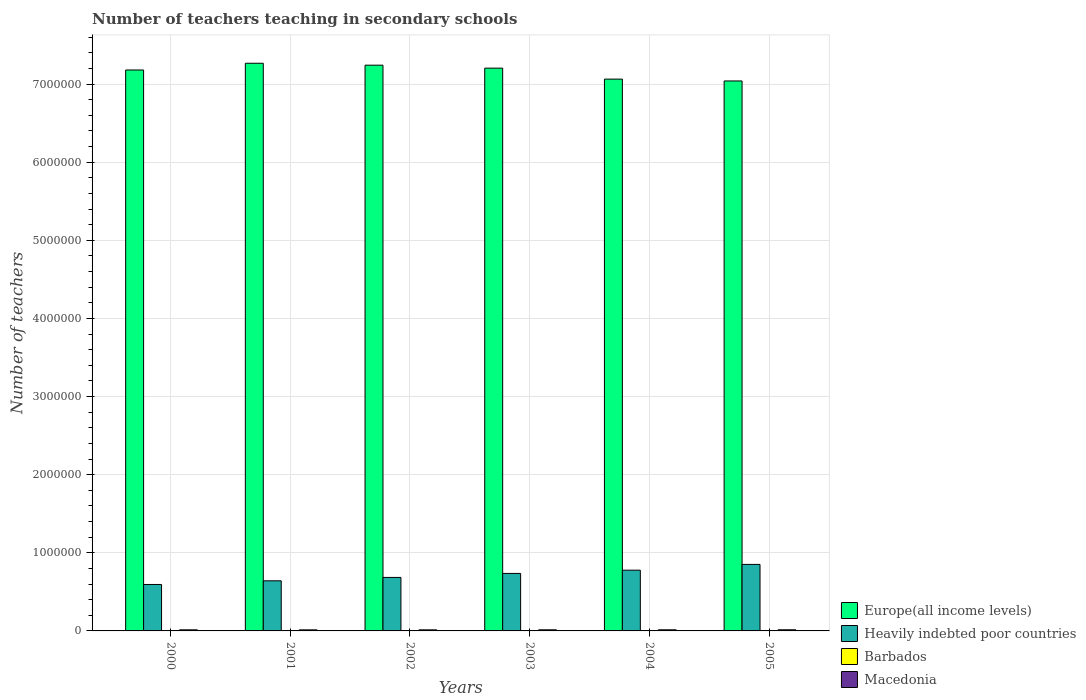Are the number of bars per tick equal to the number of legend labels?
Give a very brief answer. Yes. Are the number of bars on each tick of the X-axis equal?
Make the answer very short. Yes. How many bars are there on the 2nd tick from the left?
Give a very brief answer. 4. How many bars are there on the 5th tick from the right?
Offer a terse response. 4. What is the label of the 4th group of bars from the left?
Keep it short and to the point. 2003. What is the number of teachers teaching in secondary schools in Barbados in 2000?
Ensure brevity in your answer.  1215. Across all years, what is the maximum number of teachers teaching in secondary schools in Macedonia?
Provide a short and direct response. 1.46e+04. Across all years, what is the minimum number of teachers teaching in secondary schools in Heavily indebted poor countries?
Make the answer very short. 5.95e+05. In which year was the number of teachers teaching in secondary schools in Barbados minimum?
Your answer should be compact. 2001. What is the total number of teachers teaching in secondary schools in Heavily indebted poor countries in the graph?
Your answer should be very brief. 4.29e+06. What is the difference between the number of teachers teaching in secondary schools in Europe(all income levels) in 2002 and that in 2005?
Make the answer very short. 2.02e+05. What is the difference between the number of teachers teaching in secondary schools in Macedonia in 2000 and the number of teachers teaching in secondary schools in Barbados in 2003?
Provide a short and direct response. 1.25e+04. What is the average number of teachers teaching in secondary schools in Europe(all income levels) per year?
Provide a succinct answer. 7.17e+06. In the year 2004, what is the difference between the number of teachers teaching in secondary schools in Heavily indebted poor countries and number of teachers teaching in secondary schools in Macedonia?
Keep it short and to the point. 7.63e+05. In how many years, is the number of teachers teaching in secondary schools in Macedonia greater than 5200000?
Your answer should be compact. 0. What is the ratio of the number of teachers teaching in secondary schools in Europe(all income levels) in 2003 to that in 2005?
Offer a very short reply. 1.02. Is the difference between the number of teachers teaching in secondary schools in Heavily indebted poor countries in 2001 and 2005 greater than the difference between the number of teachers teaching in secondary schools in Macedonia in 2001 and 2005?
Give a very brief answer. No. What is the difference between the highest and the second highest number of teachers teaching in secondary schools in Europe(all income levels)?
Give a very brief answer. 2.47e+04. What is the difference between the highest and the lowest number of teachers teaching in secondary schools in Macedonia?
Ensure brevity in your answer.  979. What does the 2nd bar from the left in 2004 represents?
Give a very brief answer. Heavily indebted poor countries. What does the 3rd bar from the right in 2001 represents?
Give a very brief answer. Heavily indebted poor countries. Is it the case that in every year, the sum of the number of teachers teaching in secondary schools in Barbados and number of teachers teaching in secondary schools in Macedonia is greater than the number of teachers teaching in secondary schools in Heavily indebted poor countries?
Keep it short and to the point. No. How many bars are there?
Provide a short and direct response. 24. Are all the bars in the graph horizontal?
Keep it short and to the point. No. How many years are there in the graph?
Provide a short and direct response. 6. What is the difference between two consecutive major ticks on the Y-axis?
Your response must be concise. 1.00e+06. Does the graph contain any zero values?
Provide a succinct answer. No. How many legend labels are there?
Offer a very short reply. 4. How are the legend labels stacked?
Ensure brevity in your answer.  Vertical. What is the title of the graph?
Offer a very short reply. Number of teachers teaching in secondary schools. Does "Somalia" appear as one of the legend labels in the graph?
Your answer should be very brief. No. What is the label or title of the Y-axis?
Provide a short and direct response. Number of teachers. What is the Number of teachers of Europe(all income levels) in 2000?
Your answer should be very brief. 7.18e+06. What is the Number of teachers in Heavily indebted poor countries in 2000?
Provide a short and direct response. 5.95e+05. What is the Number of teachers in Barbados in 2000?
Keep it short and to the point. 1215. What is the Number of teachers of Macedonia in 2000?
Provide a succinct answer. 1.38e+04. What is the Number of teachers of Europe(all income levels) in 2001?
Offer a terse response. 7.27e+06. What is the Number of teachers of Heavily indebted poor countries in 2001?
Your response must be concise. 6.42e+05. What is the Number of teachers of Barbados in 2001?
Provide a short and direct response. 1210. What is the Number of teachers of Macedonia in 2001?
Offer a very short reply. 1.36e+04. What is the Number of teachers in Europe(all income levels) in 2002?
Offer a terse response. 7.24e+06. What is the Number of teachers of Heavily indebted poor countries in 2002?
Ensure brevity in your answer.  6.85e+05. What is the Number of teachers of Barbados in 2002?
Offer a terse response. 1326. What is the Number of teachers of Macedonia in 2002?
Provide a short and direct response. 1.36e+04. What is the Number of teachers in Europe(all income levels) in 2003?
Your answer should be compact. 7.20e+06. What is the Number of teachers of Heavily indebted poor countries in 2003?
Your answer should be compact. 7.36e+05. What is the Number of teachers in Barbados in 2003?
Keep it short and to the point. 1381. What is the Number of teachers of Macedonia in 2003?
Make the answer very short. 1.40e+04. What is the Number of teachers in Europe(all income levels) in 2004?
Your answer should be very brief. 7.06e+06. What is the Number of teachers in Heavily indebted poor countries in 2004?
Provide a succinct answer. 7.78e+05. What is the Number of teachers of Barbados in 2004?
Make the answer very short. 1264. What is the Number of teachers of Macedonia in 2004?
Offer a terse response. 1.43e+04. What is the Number of teachers in Europe(all income levels) in 2005?
Ensure brevity in your answer.  7.04e+06. What is the Number of teachers in Heavily indebted poor countries in 2005?
Keep it short and to the point. 8.52e+05. What is the Number of teachers in Barbados in 2005?
Offer a terse response. 1348. What is the Number of teachers of Macedonia in 2005?
Your response must be concise. 1.46e+04. Across all years, what is the maximum Number of teachers in Europe(all income levels)?
Offer a very short reply. 7.27e+06. Across all years, what is the maximum Number of teachers in Heavily indebted poor countries?
Make the answer very short. 8.52e+05. Across all years, what is the maximum Number of teachers of Barbados?
Make the answer very short. 1381. Across all years, what is the maximum Number of teachers of Macedonia?
Keep it short and to the point. 1.46e+04. Across all years, what is the minimum Number of teachers in Europe(all income levels)?
Your answer should be compact. 7.04e+06. Across all years, what is the minimum Number of teachers of Heavily indebted poor countries?
Your response must be concise. 5.95e+05. Across all years, what is the minimum Number of teachers in Barbados?
Your response must be concise. 1210. Across all years, what is the minimum Number of teachers of Macedonia?
Offer a terse response. 1.36e+04. What is the total Number of teachers in Europe(all income levels) in the graph?
Keep it short and to the point. 4.30e+07. What is the total Number of teachers in Heavily indebted poor countries in the graph?
Offer a very short reply. 4.29e+06. What is the total Number of teachers in Barbados in the graph?
Ensure brevity in your answer.  7744. What is the total Number of teachers in Macedonia in the graph?
Ensure brevity in your answer.  8.38e+04. What is the difference between the Number of teachers of Europe(all income levels) in 2000 and that in 2001?
Ensure brevity in your answer.  -8.63e+04. What is the difference between the Number of teachers in Heavily indebted poor countries in 2000 and that in 2001?
Give a very brief answer. -4.70e+04. What is the difference between the Number of teachers of Barbados in 2000 and that in 2001?
Keep it short and to the point. 5. What is the difference between the Number of teachers of Macedonia in 2000 and that in 2001?
Keep it short and to the point. 262. What is the difference between the Number of teachers of Europe(all income levels) in 2000 and that in 2002?
Your answer should be compact. -6.16e+04. What is the difference between the Number of teachers in Heavily indebted poor countries in 2000 and that in 2002?
Provide a succinct answer. -9.01e+04. What is the difference between the Number of teachers of Barbados in 2000 and that in 2002?
Provide a succinct answer. -111. What is the difference between the Number of teachers of Macedonia in 2000 and that in 2002?
Give a very brief answer. 203. What is the difference between the Number of teachers in Europe(all income levels) in 2000 and that in 2003?
Keep it short and to the point. -2.36e+04. What is the difference between the Number of teachers in Heavily indebted poor countries in 2000 and that in 2003?
Your answer should be very brief. -1.41e+05. What is the difference between the Number of teachers of Barbados in 2000 and that in 2003?
Offer a very short reply. -166. What is the difference between the Number of teachers of Macedonia in 2000 and that in 2003?
Your answer should be very brief. -172. What is the difference between the Number of teachers of Europe(all income levels) in 2000 and that in 2004?
Your answer should be very brief. 1.17e+05. What is the difference between the Number of teachers in Heavily indebted poor countries in 2000 and that in 2004?
Your answer should be compact. -1.83e+05. What is the difference between the Number of teachers in Barbados in 2000 and that in 2004?
Your answer should be compact. -49. What is the difference between the Number of teachers in Macedonia in 2000 and that in 2004?
Offer a very short reply. -427. What is the difference between the Number of teachers in Europe(all income levels) in 2000 and that in 2005?
Provide a succinct answer. 1.40e+05. What is the difference between the Number of teachers of Heavily indebted poor countries in 2000 and that in 2005?
Give a very brief answer. -2.57e+05. What is the difference between the Number of teachers in Barbados in 2000 and that in 2005?
Offer a terse response. -133. What is the difference between the Number of teachers in Macedonia in 2000 and that in 2005?
Your answer should be very brief. -717. What is the difference between the Number of teachers in Europe(all income levels) in 2001 and that in 2002?
Offer a terse response. 2.47e+04. What is the difference between the Number of teachers of Heavily indebted poor countries in 2001 and that in 2002?
Your answer should be very brief. -4.31e+04. What is the difference between the Number of teachers in Barbados in 2001 and that in 2002?
Your answer should be very brief. -116. What is the difference between the Number of teachers of Macedonia in 2001 and that in 2002?
Ensure brevity in your answer.  -59. What is the difference between the Number of teachers of Europe(all income levels) in 2001 and that in 2003?
Your answer should be very brief. 6.26e+04. What is the difference between the Number of teachers in Heavily indebted poor countries in 2001 and that in 2003?
Provide a succinct answer. -9.43e+04. What is the difference between the Number of teachers of Barbados in 2001 and that in 2003?
Offer a very short reply. -171. What is the difference between the Number of teachers of Macedonia in 2001 and that in 2003?
Make the answer very short. -434. What is the difference between the Number of teachers of Europe(all income levels) in 2001 and that in 2004?
Ensure brevity in your answer.  2.03e+05. What is the difference between the Number of teachers in Heavily indebted poor countries in 2001 and that in 2004?
Keep it short and to the point. -1.36e+05. What is the difference between the Number of teachers in Barbados in 2001 and that in 2004?
Your answer should be very brief. -54. What is the difference between the Number of teachers in Macedonia in 2001 and that in 2004?
Ensure brevity in your answer.  -689. What is the difference between the Number of teachers in Europe(all income levels) in 2001 and that in 2005?
Your response must be concise. 2.27e+05. What is the difference between the Number of teachers of Heavily indebted poor countries in 2001 and that in 2005?
Keep it short and to the point. -2.10e+05. What is the difference between the Number of teachers of Barbados in 2001 and that in 2005?
Keep it short and to the point. -138. What is the difference between the Number of teachers of Macedonia in 2001 and that in 2005?
Give a very brief answer. -979. What is the difference between the Number of teachers in Europe(all income levels) in 2002 and that in 2003?
Offer a very short reply. 3.80e+04. What is the difference between the Number of teachers of Heavily indebted poor countries in 2002 and that in 2003?
Your response must be concise. -5.12e+04. What is the difference between the Number of teachers of Barbados in 2002 and that in 2003?
Offer a very short reply. -55. What is the difference between the Number of teachers of Macedonia in 2002 and that in 2003?
Offer a very short reply. -375. What is the difference between the Number of teachers of Europe(all income levels) in 2002 and that in 2004?
Offer a very short reply. 1.78e+05. What is the difference between the Number of teachers in Heavily indebted poor countries in 2002 and that in 2004?
Offer a terse response. -9.28e+04. What is the difference between the Number of teachers of Barbados in 2002 and that in 2004?
Give a very brief answer. 62. What is the difference between the Number of teachers in Macedonia in 2002 and that in 2004?
Your response must be concise. -630. What is the difference between the Number of teachers in Europe(all income levels) in 2002 and that in 2005?
Keep it short and to the point. 2.02e+05. What is the difference between the Number of teachers of Heavily indebted poor countries in 2002 and that in 2005?
Offer a terse response. -1.67e+05. What is the difference between the Number of teachers of Barbados in 2002 and that in 2005?
Offer a very short reply. -22. What is the difference between the Number of teachers of Macedonia in 2002 and that in 2005?
Make the answer very short. -920. What is the difference between the Number of teachers in Europe(all income levels) in 2003 and that in 2004?
Ensure brevity in your answer.  1.40e+05. What is the difference between the Number of teachers in Heavily indebted poor countries in 2003 and that in 2004?
Offer a terse response. -4.17e+04. What is the difference between the Number of teachers in Barbados in 2003 and that in 2004?
Your answer should be compact. 117. What is the difference between the Number of teachers of Macedonia in 2003 and that in 2004?
Your response must be concise. -255. What is the difference between the Number of teachers in Europe(all income levels) in 2003 and that in 2005?
Keep it short and to the point. 1.64e+05. What is the difference between the Number of teachers of Heavily indebted poor countries in 2003 and that in 2005?
Provide a succinct answer. -1.16e+05. What is the difference between the Number of teachers in Macedonia in 2003 and that in 2005?
Ensure brevity in your answer.  -545. What is the difference between the Number of teachers of Europe(all income levels) in 2004 and that in 2005?
Provide a succinct answer. 2.37e+04. What is the difference between the Number of teachers of Heavily indebted poor countries in 2004 and that in 2005?
Give a very brief answer. -7.40e+04. What is the difference between the Number of teachers of Barbados in 2004 and that in 2005?
Your answer should be very brief. -84. What is the difference between the Number of teachers of Macedonia in 2004 and that in 2005?
Provide a succinct answer. -290. What is the difference between the Number of teachers of Europe(all income levels) in 2000 and the Number of teachers of Heavily indebted poor countries in 2001?
Your response must be concise. 6.54e+06. What is the difference between the Number of teachers of Europe(all income levels) in 2000 and the Number of teachers of Barbados in 2001?
Give a very brief answer. 7.18e+06. What is the difference between the Number of teachers of Europe(all income levels) in 2000 and the Number of teachers of Macedonia in 2001?
Keep it short and to the point. 7.17e+06. What is the difference between the Number of teachers in Heavily indebted poor countries in 2000 and the Number of teachers in Barbados in 2001?
Your response must be concise. 5.93e+05. What is the difference between the Number of teachers of Heavily indebted poor countries in 2000 and the Number of teachers of Macedonia in 2001?
Your answer should be very brief. 5.81e+05. What is the difference between the Number of teachers of Barbados in 2000 and the Number of teachers of Macedonia in 2001?
Provide a short and direct response. -1.24e+04. What is the difference between the Number of teachers in Europe(all income levels) in 2000 and the Number of teachers in Heavily indebted poor countries in 2002?
Offer a terse response. 6.50e+06. What is the difference between the Number of teachers in Europe(all income levels) in 2000 and the Number of teachers in Barbados in 2002?
Your answer should be very brief. 7.18e+06. What is the difference between the Number of teachers of Europe(all income levels) in 2000 and the Number of teachers of Macedonia in 2002?
Offer a terse response. 7.17e+06. What is the difference between the Number of teachers of Heavily indebted poor countries in 2000 and the Number of teachers of Barbados in 2002?
Provide a succinct answer. 5.93e+05. What is the difference between the Number of teachers in Heavily indebted poor countries in 2000 and the Number of teachers in Macedonia in 2002?
Provide a succinct answer. 5.81e+05. What is the difference between the Number of teachers in Barbados in 2000 and the Number of teachers in Macedonia in 2002?
Make the answer very short. -1.24e+04. What is the difference between the Number of teachers of Europe(all income levels) in 2000 and the Number of teachers of Heavily indebted poor countries in 2003?
Keep it short and to the point. 6.44e+06. What is the difference between the Number of teachers of Europe(all income levels) in 2000 and the Number of teachers of Barbados in 2003?
Provide a succinct answer. 7.18e+06. What is the difference between the Number of teachers of Europe(all income levels) in 2000 and the Number of teachers of Macedonia in 2003?
Give a very brief answer. 7.17e+06. What is the difference between the Number of teachers of Heavily indebted poor countries in 2000 and the Number of teachers of Barbados in 2003?
Your answer should be very brief. 5.93e+05. What is the difference between the Number of teachers of Heavily indebted poor countries in 2000 and the Number of teachers of Macedonia in 2003?
Offer a terse response. 5.81e+05. What is the difference between the Number of teachers of Barbados in 2000 and the Number of teachers of Macedonia in 2003?
Offer a terse response. -1.28e+04. What is the difference between the Number of teachers of Europe(all income levels) in 2000 and the Number of teachers of Heavily indebted poor countries in 2004?
Your answer should be compact. 6.40e+06. What is the difference between the Number of teachers of Europe(all income levels) in 2000 and the Number of teachers of Barbados in 2004?
Keep it short and to the point. 7.18e+06. What is the difference between the Number of teachers in Europe(all income levels) in 2000 and the Number of teachers in Macedonia in 2004?
Give a very brief answer. 7.17e+06. What is the difference between the Number of teachers of Heavily indebted poor countries in 2000 and the Number of teachers of Barbados in 2004?
Offer a terse response. 5.93e+05. What is the difference between the Number of teachers of Heavily indebted poor countries in 2000 and the Number of teachers of Macedonia in 2004?
Provide a short and direct response. 5.80e+05. What is the difference between the Number of teachers in Barbados in 2000 and the Number of teachers in Macedonia in 2004?
Make the answer very short. -1.30e+04. What is the difference between the Number of teachers in Europe(all income levels) in 2000 and the Number of teachers in Heavily indebted poor countries in 2005?
Offer a terse response. 6.33e+06. What is the difference between the Number of teachers of Europe(all income levels) in 2000 and the Number of teachers of Barbados in 2005?
Your answer should be compact. 7.18e+06. What is the difference between the Number of teachers in Europe(all income levels) in 2000 and the Number of teachers in Macedonia in 2005?
Ensure brevity in your answer.  7.17e+06. What is the difference between the Number of teachers in Heavily indebted poor countries in 2000 and the Number of teachers in Barbados in 2005?
Offer a terse response. 5.93e+05. What is the difference between the Number of teachers of Heavily indebted poor countries in 2000 and the Number of teachers of Macedonia in 2005?
Make the answer very short. 5.80e+05. What is the difference between the Number of teachers in Barbados in 2000 and the Number of teachers in Macedonia in 2005?
Give a very brief answer. -1.33e+04. What is the difference between the Number of teachers of Europe(all income levels) in 2001 and the Number of teachers of Heavily indebted poor countries in 2002?
Provide a short and direct response. 6.58e+06. What is the difference between the Number of teachers of Europe(all income levels) in 2001 and the Number of teachers of Barbados in 2002?
Provide a succinct answer. 7.27e+06. What is the difference between the Number of teachers in Europe(all income levels) in 2001 and the Number of teachers in Macedonia in 2002?
Provide a short and direct response. 7.25e+06. What is the difference between the Number of teachers of Heavily indebted poor countries in 2001 and the Number of teachers of Barbados in 2002?
Your response must be concise. 6.40e+05. What is the difference between the Number of teachers in Heavily indebted poor countries in 2001 and the Number of teachers in Macedonia in 2002?
Ensure brevity in your answer.  6.28e+05. What is the difference between the Number of teachers of Barbados in 2001 and the Number of teachers of Macedonia in 2002?
Ensure brevity in your answer.  -1.24e+04. What is the difference between the Number of teachers in Europe(all income levels) in 2001 and the Number of teachers in Heavily indebted poor countries in 2003?
Offer a terse response. 6.53e+06. What is the difference between the Number of teachers of Europe(all income levels) in 2001 and the Number of teachers of Barbados in 2003?
Your answer should be compact. 7.27e+06. What is the difference between the Number of teachers of Europe(all income levels) in 2001 and the Number of teachers of Macedonia in 2003?
Provide a short and direct response. 7.25e+06. What is the difference between the Number of teachers of Heavily indebted poor countries in 2001 and the Number of teachers of Barbados in 2003?
Give a very brief answer. 6.40e+05. What is the difference between the Number of teachers in Heavily indebted poor countries in 2001 and the Number of teachers in Macedonia in 2003?
Offer a very short reply. 6.28e+05. What is the difference between the Number of teachers of Barbados in 2001 and the Number of teachers of Macedonia in 2003?
Provide a short and direct response. -1.28e+04. What is the difference between the Number of teachers in Europe(all income levels) in 2001 and the Number of teachers in Heavily indebted poor countries in 2004?
Provide a succinct answer. 6.49e+06. What is the difference between the Number of teachers in Europe(all income levels) in 2001 and the Number of teachers in Barbados in 2004?
Give a very brief answer. 7.27e+06. What is the difference between the Number of teachers in Europe(all income levels) in 2001 and the Number of teachers in Macedonia in 2004?
Make the answer very short. 7.25e+06. What is the difference between the Number of teachers in Heavily indebted poor countries in 2001 and the Number of teachers in Barbados in 2004?
Ensure brevity in your answer.  6.40e+05. What is the difference between the Number of teachers in Heavily indebted poor countries in 2001 and the Number of teachers in Macedonia in 2004?
Provide a short and direct response. 6.27e+05. What is the difference between the Number of teachers in Barbados in 2001 and the Number of teachers in Macedonia in 2004?
Offer a very short reply. -1.30e+04. What is the difference between the Number of teachers in Europe(all income levels) in 2001 and the Number of teachers in Heavily indebted poor countries in 2005?
Offer a terse response. 6.42e+06. What is the difference between the Number of teachers of Europe(all income levels) in 2001 and the Number of teachers of Barbados in 2005?
Your answer should be compact. 7.27e+06. What is the difference between the Number of teachers in Europe(all income levels) in 2001 and the Number of teachers in Macedonia in 2005?
Keep it short and to the point. 7.25e+06. What is the difference between the Number of teachers in Heavily indebted poor countries in 2001 and the Number of teachers in Barbados in 2005?
Give a very brief answer. 6.40e+05. What is the difference between the Number of teachers in Heavily indebted poor countries in 2001 and the Number of teachers in Macedonia in 2005?
Ensure brevity in your answer.  6.27e+05. What is the difference between the Number of teachers in Barbados in 2001 and the Number of teachers in Macedonia in 2005?
Make the answer very short. -1.33e+04. What is the difference between the Number of teachers of Europe(all income levels) in 2002 and the Number of teachers of Heavily indebted poor countries in 2003?
Your response must be concise. 6.51e+06. What is the difference between the Number of teachers of Europe(all income levels) in 2002 and the Number of teachers of Barbados in 2003?
Offer a terse response. 7.24e+06. What is the difference between the Number of teachers in Europe(all income levels) in 2002 and the Number of teachers in Macedonia in 2003?
Your answer should be very brief. 7.23e+06. What is the difference between the Number of teachers in Heavily indebted poor countries in 2002 and the Number of teachers in Barbados in 2003?
Offer a terse response. 6.83e+05. What is the difference between the Number of teachers in Heavily indebted poor countries in 2002 and the Number of teachers in Macedonia in 2003?
Give a very brief answer. 6.71e+05. What is the difference between the Number of teachers in Barbados in 2002 and the Number of teachers in Macedonia in 2003?
Provide a succinct answer. -1.27e+04. What is the difference between the Number of teachers in Europe(all income levels) in 2002 and the Number of teachers in Heavily indebted poor countries in 2004?
Keep it short and to the point. 6.46e+06. What is the difference between the Number of teachers of Europe(all income levels) in 2002 and the Number of teachers of Barbados in 2004?
Your answer should be compact. 7.24e+06. What is the difference between the Number of teachers in Europe(all income levels) in 2002 and the Number of teachers in Macedonia in 2004?
Provide a short and direct response. 7.23e+06. What is the difference between the Number of teachers of Heavily indebted poor countries in 2002 and the Number of teachers of Barbados in 2004?
Your response must be concise. 6.83e+05. What is the difference between the Number of teachers in Heavily indebted poor countries in 2002 and the Number of teachers in Macedonia in 2004?
Your answer should be very brief. 6.70e+05. What is the difference between the Number of teachers in Barbados in 2002 and the Number of teachers in Macedonia in 2004?
Your answer should be very brief. -1.29e+04. What is the difference between the Number of teachers in Europe(all income levels) in 2002 and the Number of teachers in Heavily indebted poor countries in 2005?
Your answer should be compact. 6.39e+06. What is the difference between the Number of teachers in Europe(all income levels) in 2002 and the Number of teachers in Barbados in 2005?
Make the answer very short. 7.24e+06. What is the difference between the Number of teachers of Europe(all income levels) in 2002 and the Number of teachers of Macedonia in 2005?
Your answer should be compact. 7.23e+06. What is the difference between the Number of teachers in Heavily indebted poor countries in 2002 and the Number of teachers in Barbados in 2005?
Your response must be concise. 6.83e+05. What is the difference between the Number of teachers of Heavily indebted poor countries in 2002 and the Number of teachers of Macedonia in 2005?
Your answer should be compact. 6.70e+05. What is the difference between the Number of teachers in Barbados in 2002 and the Number of teachers in Macedonia in 2005?
Your answer should be compact. -1.32e+04. What is the difference between the Number of teachers in Europe(all income levels) in 2003 and the Number of teachers in Heavily indebted poor countries in 2004?
Your answer should be very brief. 6.43e+06. What is the difference between the Number of teachers in Europe(all income levels) in 2003 and the Number of teachers in Barbados in 2004?
Provide a succinct answer. 7.20e+06. What is the difference between the Number of teachers in Europe(all income levels) in 2003 and the Number of teachers in Macedonia in 2004?
Give a very brief answer. 7.19e+06. What is the difference between the Number of teachers in Heavily indebted poor countries in 2003 and the Number of teachers in Barbados in 2004?
Give a very brief answer. 7.35e+05. What is the difference between the Number of teachers in Heavily indebted poor countries in 2003 and the Number of teachers in Macedonia in 2004?
Offer a terse response. 7.22e+05. What is the difference between the Number of teachers of Barbados in 2003 and the Number of teachers of Macedonia in 2004?
Your answer should be compact. -1.29e+04. What is the difference between the Number of teachers in Europe(all income levels) in 2003 and the Number of teachers in Heavily indebted poor countries in 2005?
Provide a succinct answer. 6.35e+06. What is the difference between the Number of teachers of Europe(all income levels) in 2003 and the Number of teachers of Barbados in 2005?
Provide a succinct answer. 7.20e+06. What is the difference between the Number of teachers in Europe(all income levels) in 2003 and the Number of teachers in Macedonia in 2005?
Provide a short and direct response. 7.19e+06. What is the difference between the Number of teachers in Heavily indebted poor countries in 2003 and the Number of teachers in Barbados in 2005?
Offer a very short reply. 7.35e+05. What is the difference between the Number of teachers in Heavily indebted poor countries in 2003 and the Number of teachers in Macedonia in 2005?
Your answer should be compact. 7.21e+05. What is the difference between the Number of teachers in Barbados in 2003 and the Number of teachers in Macedonia in 2005?
Your response must be concise. -1.32e+04. What is the difference between the Number of teachers of Europe(all income levels) in 2004 and the Number of teachers of Heavily indebted poor countries in 2005?
Provide a short and direct response. 6.21e+06. What is the difference between the Number of teachers in Europe(all income levels) in 2004 and the Number of teachers in Barbados in 2005?
Make the answer very short. 7.06e+06. What is the difference between the Number of teachers in Europe(all income levels) in 2004 and the Number of teachers in Macedonia in 2005?
Ensure brevity in your answer.  7.05e+06. What is the difference between the Number of teachers in Heavily indebted poor countries in 2004 and the Number of teachers in Barbados in 2005?
Provide a succinct answer. 7.76e+05. What is the difference between the Number of teachers of Heavily indebted poor countries in 2004 and the Number of teachers of Macedonia in 2005?
Ensure brevity in your answer.  7.63e+05. What is the difference between the Number of teachers of Barbados in 2004 and the Number of teachers of Macedonia in 2005?
Provide a succinct answer. -1.33e+04. What is the average Number of teachers of Europe(all income levels) per year?
Keep it short and to the point. 7.17e+06. What is the average Number of teachers of Heavily indebted poor countries per year?
Your answer should be compact. 7.14e+05. What is the average Number of teachers of Barbados per year?
Make the answer very short. 1290.67. What is the average Number of teachers of Macedonia per year?
Make the answer very short. 1.40e+04. In the year 2000, what is the difference between the Number of teachers of Europe(all income levels) and Number of teachers of Heavily indebted poor countries?
Provide a short and direct response. 6.59e+06. In the year 2000, what is the difference between the Number of teachers in Europe(all income levels) and Number of teachers in Barbados?
Provide a succinct answer. 7.18e+06. In the year 2000, what is the difference between the Number of teachers of Europe(all income levels) and Number of teachers of Macedonia?
Your answer should be very brief. 7.17e+06. In the year 2000, what is the difference between the Number of teachers of Heavily indebted poor countries and Number of teachers of Barbados?
Ensure brevity in your answer.  5.93e+05. In the year 2000, what is the difference between the Number of teachers of Heavily indebted poor countries and Number of teachers of Macedonia?
Your answer should be very brief. 5.81e+05. In the year 2000, what is the difference between the Number of teachers in Barbados and Number of teachers in Macedonia?
Provide a short and direct response. -1.26e+04. In the year 2001, what is the difference between the Number of teachers in Europe(all income levels) and Number of teachers in Heavily indebted poor countries?
Offer a terse response. 6.63e+06. In the year 2001, what is the difference between the Number of teachers in Europe(all income levels) and Number of teachers in Barbados?
Ensure brevity in your answer.  7.27e+06. In the year 2001, what is the difference between the Number of teachers of Europe(all income levels) and Number of teachers of Macedonia?
Offer a very short reply. 7.25e+06. In the year 2001, what is the difference between the Number of teachers of Heavily indebted poor countries and Number of teachers of Barbados?
Your answer should be very brief. 6.40e+05. In the year 2001, what is the difference between the Number of teachers in Heavily indebted poor countries and Number of teachers in Macedonia?
Offer a terse response. 6.28e+05. In the year 2001, what is the difference between the Number of teachers in Barbados and Number of teachers in Macedonia?
Give a very brief answer. -1.24e+04. In the year 2002, what is the difference between the Number of teachers in Europe(all income levels) and Number of teachers in Heavily indebted poor countries?
Offer a terse response. 6.56e+06. In the year 2002, what is the difference between the Number of teachers in Europe(all income levels) and Number of teachers in Barbados?
Offer a very short reply. 7.24e+06. In the year 2002, what is the difference between the Number of teachers of Europe(all income levels) and Number of teachers of Macedonia?
Your answer should be very brief. 7.23e+06. In the year 2002, what is the difference between the Number of teachers in Heavily indebted poor countries and Number of teachers in Barbados?
Keep it short and to the point. 6.83e+05. In the year 2002, what is the difference between the Number of teachers of Heavily indebted poor countries and Number of teachers of Macedonia?
Provide a succinct answer. 6.71e+05. In the year 2002, what is the difference between the Number of teachers in Barbados and Number of teachers in Macedonia?
Offer a terse response. -1.23e+04. In the year 2003, what is the difference between the Number of teachers of Europe(all income levels) and Number of teachers of Heavily indebted poor countries?
Provide a short and direct response. 6.47e+06. In the year 2003, what is the difference between the Number of teachers of Europe(all income levels) and Number of teachers of Barbados?
Make the answer very short. 7.20e+06. In the year 2003, what is the difference between the Number of teachers in Europe(all income levels) and Number of teachers in Macedonia?
Give a very brief answer. 7.19e+06. In the year 2003, what is the difference between the Number of teachers of Heavily indebted poor countries and Number of teachers of Barbados?
Provide a succinct answer. 7.35e+05. In the year 2003, what is the difference between the Number of teachers of Heavily indebted poor countries and Number of teachers of Macedonia?
Provide a short and direct response. 7.22e+05. In the year 2003, what is the difference between the Number of teachers of Barbados and Number of teachers of Macedonia?
Provide a short and direct response. -1.26e+04. In the year 2004, what is the difference between the Number of teachers in Europe(all income levels) and Number of teachers in Heavily indebted poor countries?
Ensure brevity in your answer.  6.29e+06. In the year 2004, what is the difference between the Number of teachers of Europe(all income levels) and Number of teachers of Barbados?
Your answer should be compact. 7.06e+06. In the year 2004, what is the difference between the Number of teachers in Europe(all income levels) and Number of teachers in Macedonia?
Keep it short and to the point. 7.05e+06. In the year 2004, what is the difference between the Number of teachers in Heavily indebted poor countries and Number of teachers in Barbados?
Your answer should be compact. 7.76e+05. In the year 2004, what is the difference between the Number of teachers of Heavily indebted poor countries and Number of teachers of Macedonia?
Your answer should be compact. 7.63e+05. In the year 2004, what is the difference between the Number of teachers of Barbados and Number of teachers of Macedonia?
Ensure brevity in your answer.  -1.30e+04. In the year 2005, what is the difference between the Number of teachers in Europe(all income levels) and Number of teachers in Heavily indebted poor countries?
Keep it short and to the point. 6.19e+06. In the year 2005, what is the difference between the Number of teachers of Europe(all income levels) and Number of teachers of Barbados?
Your answer should be very brief. 7.04e+06. In the year 2005, what is the difference between the Number of teachers in Europe(all income levels) and Number of teachers in Macedonia?
Make the answer very short. 7.03e+06. In the year 2005, what is the difference between the Number of teachers in Heavily indebted poor countries and Number of teachers in Barbados?
Provide a short and direct response. 8.50e+05. In the year 2005, what is the difference between the Number of teachers of Heavily indebted poor countries and Number of teachers of Macedonia?
Provide a short and direct response. 8.37e+05. In the year 2005, what is the difference between the Number of teachers of Barbados and Number of teachers of Macedonia?
Your response must be concise. -1.32e+04. What is the ratio of the Number of teachers in Heavily indebted poor countries in 2000 to that in 2001?
Offer a very short reply. 0.93. What is the ratio of the Number of teachers of Macedonia in 2000 to that in 2001?
Make the answer very short. 1.02. What is the ratio of the Number of teachers of Europe(all income levels) in 2000 to that in 2002?
Provide a short and direct response. 0.99. What is the ratio of the Number of teachers in Heavily indebted poor countries in 2000 to that in 2002?
Your answer should be very brief. 0.87. What is the ratio of the Number of teachers in Barbados in 2000 to that in 2002?
Give a very brief answer. 0.92. What is the ratio of the Number of teachers in Macedonia in 2000 to that in 2002?
Offer a very short reply. 1.01. What is the ratio of the Number of teachers in Heavily indebted poor countries in 2000 to that in 2003?
Your response must be concise. 0.81. What is the ratio of the Number of teachers in Barbados in 2000 to that in 2003?
Offer a very short reply. 0.88. What is the ratio of the Number of teachers in Macedonia in 2000 to that in 2003?
Give a very brief answer. 0.99. What is the ratio of the Number of teachers in Europe(all income levels) in 2000 to that in 2004?
Your answer should be very brief. 1.02. What is the ratio of the Number of teachers in Heavily indebted poor countries in 2000 to that in 2004?
Your answer should be very brief. 0.76. What is the ratio of the Number of teachers in Barbados in 2000 to that in 2004?
Offer a terse response. 0.96. What is the ratio of the Number of teachers of Macedonia in 2000 to that in 2004?
Your answer should be compact. 0.97. What is the ratio of the Number of teachers of Europe(all income levels) in 2000 to that in 2005?
Give a very brief answer. 1.02. What is the ratio of the Number of teachers in Heavily indebted poor countries in 2000 to that in 2005?
Your response must be concise. 0.7. What is the ratio of the Number of teachers in Barbados in 2000 to that in 2005?
Keep it short and to the point. 0.9. What is the ratio of the Number of teachers in Macedonia in 2000 to that in 2005?
Your response must be concise. 0.95. What is the ratio of the Number of teachers in Heavily indebted poor countries in 2001 to that in 2002?
Offer a very short reply. 0.94. What is the ratio of the Number of teachers in Barbados in 2001 to that in 2002?
Give a very brief answer. 0.91. What is the ratio of the Number of teachers of Macedonia in 2001 to that in 2002?
Your response must be concise. 1. What is the ratio of the Number of teachers of Europe(all income levels) in 2001 to that in 2003?
Offer a terse response. 1.01. What is the ratio of the Number of teachers of Heavily indebted poor countries in 2001 to that in 2003?
Your answer should be compact. 0.87. What is the ratio of the Number of teachers in Barbados in 2001 to that in 2003?
Give a very brief answer. 0.88. What is the ratio of the Number of teachers in Macedonia in 2001 to that in 2003?
Keep it short and to the point. 0.97. What is the ratio of the Number of teachers in Europe(all income levels) in 2001 to that in 2004?
Make the answer very short. 1.03. What is the ratio of the Number of teachers in Heavily indebted poor countries in 2001 to that in 2004?
Make the answer very short. 0.83. What is the ratio of the Number of teachers of Barbados in 2001 to that in 2004?
Make the answer very short. 0.96. What is the ratio of the Number of teachers of Macedonia in 2001 to that in 2004?
Ensure brevity in your answer.  0.95. What is the ratio of the Number of teachers of Europe(all income levels) in 2001 to that in 2005?
Offer a very short reply. 1.03. What is the ratio of the Number of teachers in Heavily indebted poor countries in 2001 to that in 2005?
Provide a short and direct response. 0.75. What is the ratio of the Number of teachers in Barbados in 2001 to that in 2005?
Your response must be concise. 0.9. What is the ratio of the Number of teachers in Macedonia in 2001 to that in 2005?
Give a very brief answer. 0.93. What is the ratio of the Number of teachers of Europe(all income levels) in 2002 to that in 2003?
Give a very brief answer. 1.01. What is the ratio of the Number of teachers of Heavily indebted poor countries in 2002 to that in 2003?
Give a very brief answer. 0.93. What is the ratio of the Number of teachers in Barbados in 2002 to that in 2003?
Ensure brevity in your answer.  0.96. What is the ratio of the Number of teachers of Macedonia in 2002 to that in 2003?
Provide a succinct answer. 0.97. What is the ratio of the Number of teachers in Europe(all income levels) in 2002 to that in 2004?
Your answer should be very brief. 1.03. What is the ratio of the Number of teachers in Heavily indebted poor countries in 2002 to that in 2004?
Your answer should be very brief. 0.88. What is the ratio of the Number of teachers in Barbados in 2002 to that in 2004?
Make the answer very short. 1.05. What is the ratio of the Number of teachers of Macedonia in 2002 to that in 2004?
Your answer should be compact. 0.96. What is the ratio of the Number of teachers of Europe(all income levels) in 2002 to that in 2005?
Ensure brevity in your answer.  1.03. What is the ratio of the Number of teachers of Heavily indebted poor countries in 2002 to that in 2005?
Offer a very short reply. 0.8. What is the ratio of the Number of teachers of Barbados in 2002 to that in 2005?
Provide a short and direct response. 0.98. What is the ratio of the Number of teachers of Macedonia in 2002 to that in 2005?
Keep it short and to the point. 0.94. What is the ratio of the Number of teachers in Europe(all income levels) in 2003 to that in 2004?
Keep it short and to the point. 1.02. What is the ratio of the Number of teachers in Heavily indebted poor countries in 2003 to that in 2004?
Keep it short and to the point. 0.95. What is the ratio of the Number of teachers of Barbados in 2003 to that in 2004?
Your response must be concise. 1.09. What is the ratio of the Number of teachers in Macedonia in 2003 to that in 2004?
Offer a terse response. 0.98. What is the ratio of the Number of teachers in Europe(all income levels) in 2003 to that in 2005?
Provide a succinct answer. 1.02. What is the ratio of the Number of teachers in Heavily indebted poor countries in 2003 to that in 2005?
Offer a terse response. 0.86. What is the ratio of the Number of teachers in Barbados in 2003 to that in 2005?
Keep it short and to the point. 1.02. What is the ratio of the Number of teachers of Macedonia in 2003 to that in 2005?
Give a very brief answer. 0.96. What is the ratio of the Number of teachers in Heavily indebted poor countries in 2004 to that in 2005?
Your response must be concise. 0.91. What is the ratio of the Number of teachers in Barbados in 2004 to that in 2005?
Offer a terse response. 0.94. What is the ratio of the Number of teachers of Macedonia in 2004 to that in 2005?
Keep it short and to the point. 0.98. What is the difference between the highest and the second highest Number of teachers in Europe(all income levels)?
Offer a terse response. 2.47e+04. What is the difference between the highest and the second highest Number of teachers in Heavily indebted poor countries?
Make the answer very short. 7.40e+04. What is the difference between the highest and the second highest Number of teachers in Barbados?
Keep it short and to the point. 33. What is the difference between the highest and the second highest Number of teachers of Macedonia?
Provide a short and direct response. 290. What is the difference between the highest and the lowest Number of teachers in Europe(all income levels)?
Your response must be concise. 2.27e+05. What is the difference between the highest and the lowest Number of teachers of Heavily indebted poor countries?
Ensure brevity in your answer.  2.57e+05. What is the difference between the highest and the lowest Number of teachers in Barbados?
Keep it short and to the point. 171. What is the difference between the highest and the lowest Number of teachers in Macedonia?
Provide a short and direct response. 979. 